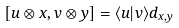<formula> <loc_0><loc_0><loc_500><loc_500>[ u \otimes x , v \otimes y ] = \langle u | v \rangle d _ { x , y }</formula> 